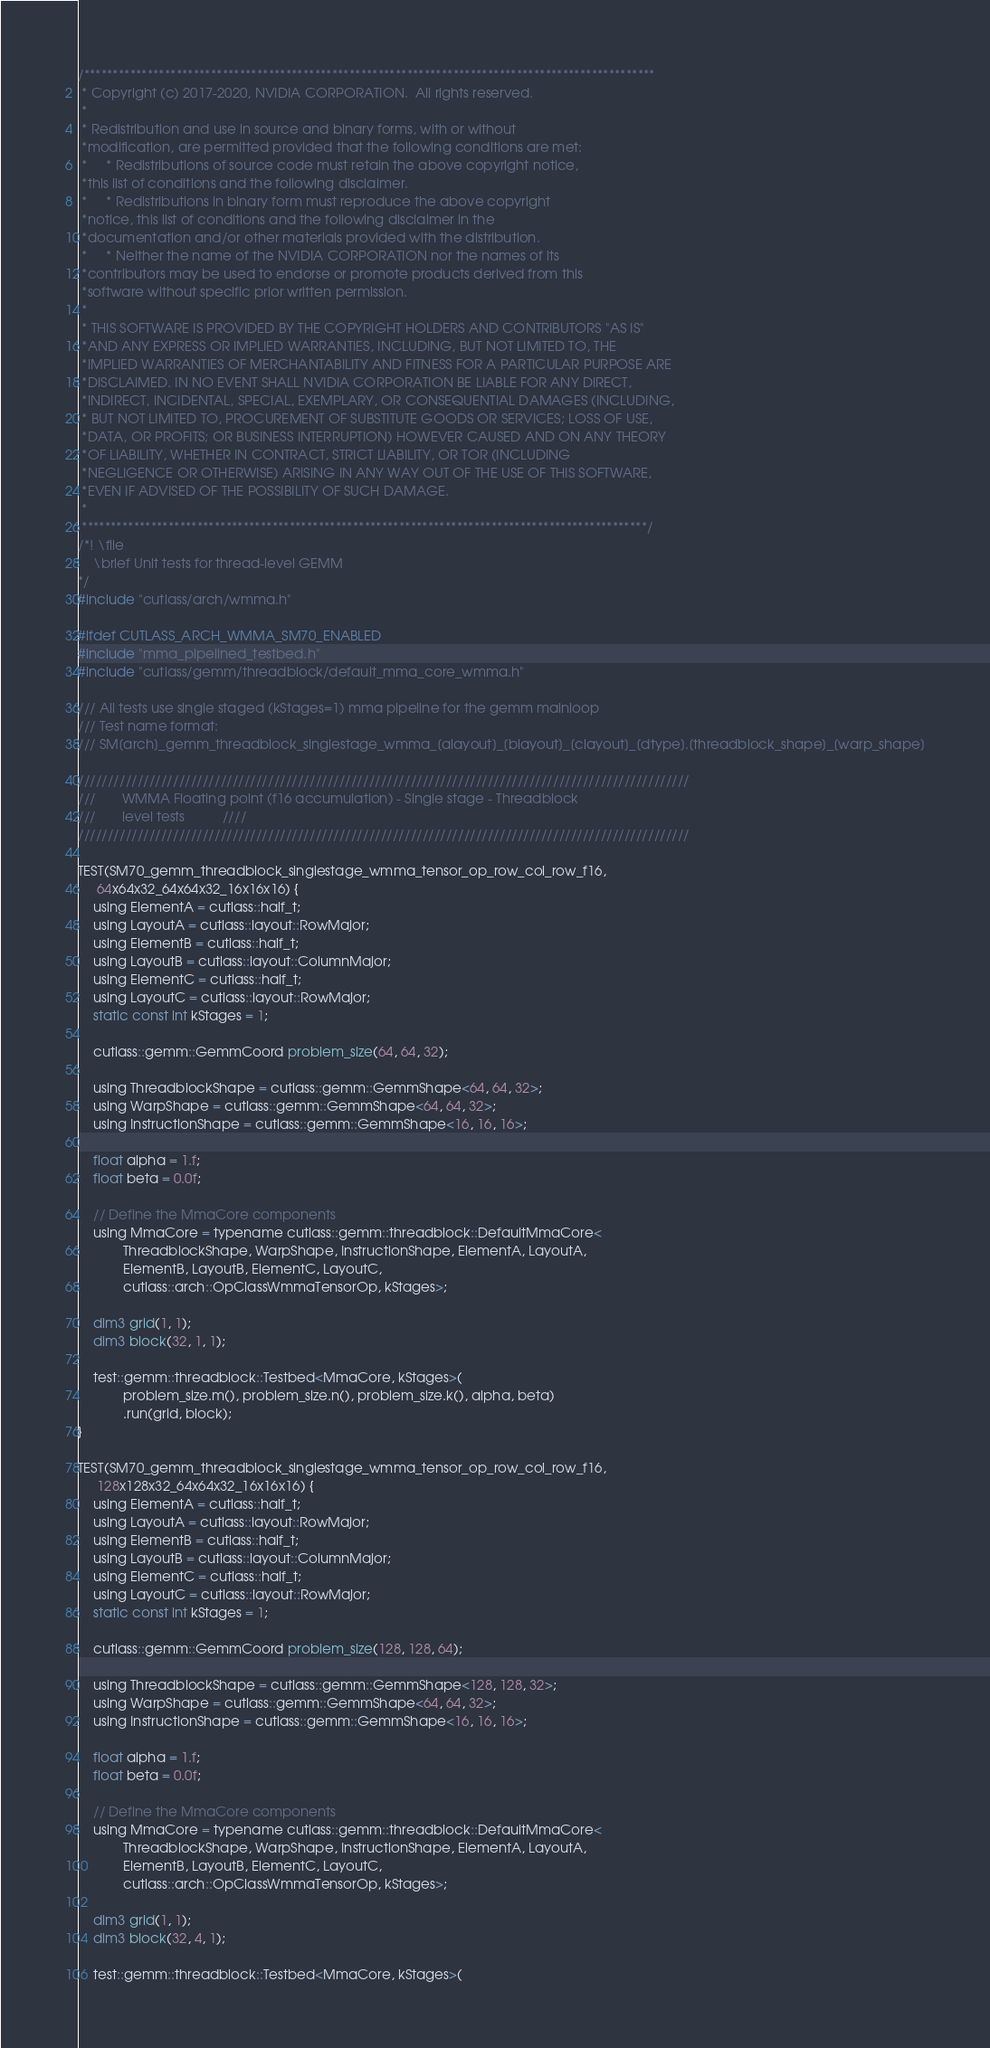<code> <loc_0><loc_0><loc_500><loc_500><_Cuda_>/***************************************************************************************************
 * Copyright (c) 2017-2020, NVIDIA CORPORATION.  All rights reserved.
 *
 * Redistribution and use in source and binary forms, with or without
 *modification, are permitted provided that the following conditions are met:
 *     * Redistributions of source code must retain the above copyright notice,
 *this list of conditions and the following disclaimer.
 *     * Redistributions in binary form must reproduce the above copyright
 *notice, this list of conditions and the following disclaimer in the
 *documentation and/or other materials provided with the distribution.
 *     * Neither the name of the NVIDIA CORPORATION nor the names of its
 *contributors may be used to endorse or promote products derived from this
 *software without specific prior written permission.
 *
 * THIS SOFTWARE IS PROVIDED BY THE COPYRIGHT HOLDERS AND CONTRIBUTORS "AS IS"
 *AND ANY EXPRESS OR IMPLIED WARRANTIES, INCLUDING, BUT NOT LIMITED TO, THE
 *IMPLIED WARRANTIES OF MERCHANTABILITY AND FITNESS FOR A PARTICULAR PURPOSE ARE
 *DISCLAIMED. IN NO EVENT SHALL NVIDIA CORPORATION BE LIABLE FOR ANY DIRECT,
 *INDIRECT, INCIDENTAL, SPECIAL, EXEMPLARY, OR CONSEQUENTIAL DAMAGES (INCLUDING,
 * BUT NOT LIMITED TO, PROCUREMENT OF SUBSTITUTE GOODS OR SERVICES; LOSS OF USE,
 *DATA, OR PROFITS; OR BUSINESS INTERRUPTION) HOWEVER CAUSED AND ON ANY THEORY
 *OF LIABILITY, WHETHER IN CONTRACT, STRICT LIABILITY, OR TOR (INCLUDING
 *NEGLIGENCE OR OTHERWISE) ARISING IN ANY WAY OUT OF THE USE OF THIS SOFTWARE,
 *EVEN IF ADVISED OF THE POSSIBILITY OF SUCH DAMAGE.
 *
 **************************************************************************************************/
/*! \file
    \brief Unit tests for thread-level GEMM
*/
#include "cutlass/arch/wmma.h"

#ifdef CUTLASS_ARCH_WMMA_SM70_ENABLED
#include "mma_pipelined_testbed.h"
#include "cutlass/gemm/threadblock/default_mma_core_wmma.h"

/// All tests use single staged (kStages=1) mma pipeline for the gemm mainloop
/// Test name format:
/// SM[arch]_gemm_threadblock_singlestage_wmma_[alayout]_[blayout]_[clayout]_[dtype].[threadblock_shape]_[warp_shape]

///////////////////////////////////////////////////////////////////////////////////////////////////////
///       WMMA Floating point (f16 accumulation) - Single stage - Threadblock
///       level tests          ////
///////////////////////////////////////////////////////////////////////////////////////////////////////

TEST(SM70_gemm_threadblock_singlestage_wmma_tensor_op_row_col_row_f16,
     64x64x32_64x64x32_16x16x16) {
    using ElementA = cutlass::half_t;
    using LayoutA = cutlass::layout::RowMajor;
    using ElementB = cutlass::half_t;
    using LayoutB = cutlass::layout::ColumnMajor;
    using ElementC = cutlass::half_t;
    using LayoutC = cutlass::layout::RowMajor;
    static const int kStages = 1;

    cutlass::gemm::GemmCoord problem_size(64, 64, 32);

    using ThreadblockShape = cutlass::gemm::GemmShape<64, 64, 32>;
    using WarpShape = cutlass::gemm::GemmShape<64, 64, 32>;
    using InstructionShape = cutlass::gemm::GemmShape<16, 16, 16>;

    float alpha = 1.f;
    float beta = 0.0f;

    // Define the MmaCore components
    using MmaCore = typename cutlass::gemm::threadblock::DefaultMmaCore<
            ThreadblockShape, WarpShape, InstructionShape, ElementA, LayoutA,
            ElementB, LayoutB, ElementC, LayoutC,
            cutlass::arch::OpClassWmmaTensorOp, kStages>;

    dim3 grid(1, 1);
    dim3 block(32, 1, 1);

    test::gemm::threadblock::Testbed<MmaCore, kStages>(
            problem_size.m(), problem_size.n(), problem_size.k(), alpha, beta)
            .run(grid, block);
}

TEST(SM70_gemm_threadblock_singlestage_wmma_tensor_op_row_col_row_f16,
     128x128x32_64x64x32_16x16x16) {
    using ElementA = cutlass::half_t;
    using LayoutA = cutlass::layout::RowMajor;
    using ElementB = cutlass::half_t;
    using LayoutB = cutlass::layout::ColumnMajor;
    using ElementC = cutlass::half_t;
    using LayoutC = cutlass::layout::RowMajor;
    static const int kStages = 1;

    cutlass::gemm::GemmCoord problem_size(128, 128, 64);

    using ThreadblockShape = cutlass::gemm::GemmShape<128, 128, 32>;
    using WarpShape = cutlass::gemm::GemmShape<64, 64, 32>;
    using InstructionShape = cutlass::gemm::GemmShape<16, 16, 16>;

    float alpha = 1.f;
    float beta = 0.0f;

    // Define the MmaCore components
    using MmaCore = typename cutlass::gemm::threadblock::DefaultMmaCore<
            ThreadblockShape, WarpShape, InstructionShape, ElementA, LayoutA,
            ElementB, LayoutB, ElementC, LayoutC,
            cutlass::arch::OpClassWmmaTensorOp, kStages>;

    dim3 grid(1, 1);
    dim3 block(32, 4, 1);

    test::gemm::threadblock::Testbed<MmaCore, kStages>(</code> 